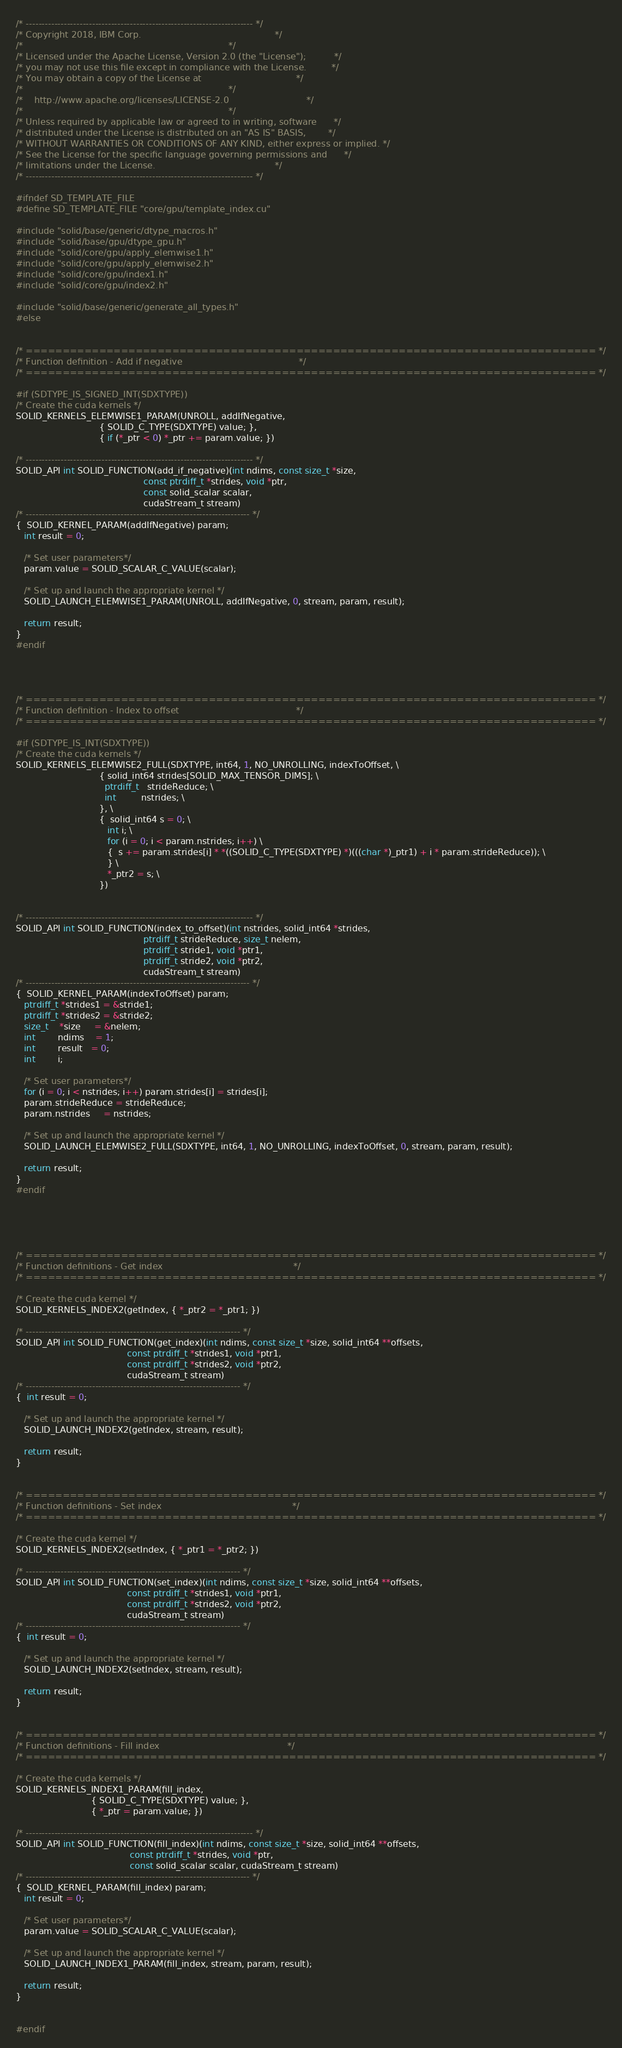Convert code to text. <code><loc_0><loc_0><loc_500><loc_500><_Cuda_>/* ------------------------------------------------------------------------ */
/* Copyright 2018, IBM Corp.                                                */
/*                                                                          */
/* Licensed under the Apache License, Version 2.0 (the "License");          */
/* you may not use this file except in compliance with the License.         */
/* You may obtain a copy of the License at                                  */
/*                                                                          */
/*    http://www.apache.org/licenses/LICENSE-2.0                            */
/*                                                                          */
/* Unless required by applicable law or agreed to in writing, software      */
/* distributed under the License is distributed on an "AS IS" BASIS,        */
/* WITHOUT WARRANTIES OR CONDITIONS OF ANY KIND, either express or implied. */
/* See the License for the specific language governing permissions and      */
/* limitations under the License.                                           */
/* ------------------------------------------------------------------------ */

#ifndef SD_TEMPLATE_FILE
#define SD_TEMPLATE_FILE "core/gpu/template_index.cu"

#include "solid/base/generic/dtype_macros.h"
#include "solid/base/gpu/dtype_gpu.h"
#include "solid/core/gpu/apply_elemwise1.h"
#include "solid/core/gpu/apply_elemwise2.h"
#include "solid/core/gpu/index1.h"
#include "solid/core/gpu/index2.h"

#include "solid/base/generic/generate_all_types.h"
#else


/* ============================================================================== */
/* Function definition - Add if negative                                          */
/* ============================================================================== */

#if (SDTYPE_IS_SIGNED_INT(SDXTYPE))
/* Create the cuda kernels */
SOLID_KERNELS_ELEMWISE1_PARAM(UNROLL, addIfNegative,
                              { SOLID_C_TYPE(SDXTYPE) value; },
                              { if (*_ptr < 0) *_ptr += param.value; })

/* ------------------------------------------------------------------------ */
SOLID_API int SOLID_FUNCTION(add_if_negative)(int ndims, const size_t *size,
                                              const ptrdiff_t *strides, void *ptr,
                                              const solid_scalar scalar,
                                              cudaStream_t stream)
/* ----------------------------------------------------------------------- */
{  SOLID_KERNEL_PARAM(addIfNegative) param;
   int result = 0;

   /* Set user parameters*/
   param.value = SOLID_SCALAR_C_VALUE(scalar);

   /* Set up and launch the appropriate kernel */
   SOLID_LAUNCH_ELEMWISE1_PARAM(UNROLL, addIfNegative, 0, stream, param, result);

   return result;
}
#endif




/* ============================================================================== */
/* Function definition - Index to offset                                          */
/* ============================================================================== */

#if (SDTYPE_IS_INT(SDXTYPE))
/* Create the cuda kernels */
SOLID_KERNELS_ELEMWISE2_FULL(SDXTYPE, int64, 1, NO_UNROLLING, indexToOffset, \
                              { solid_int64 strides[SOLID_MAX_TENSOR_DIMS]; \
                                ptrdiff_t   strideReduce; \
                                int         nstrides; \
                              }, \
                              {  solid_int64 s = 0; \
                                 int i; \
                                 for (i = 0; i < param.nstrides; i++) \
                                 {  s += param.strides[i] * *((SOLID_C_TYPE(SDXTYPE) *)(((char *)_ptr1) + i * param.strideReduce)); \
                                 } \
                                 *_ptr2 = s; \
                              })


/* ------------------------------------------------------------------------ */
SOLID_API int SOLID_FUNCTION(index_to_offset)(int nstrides, solid_int64 *strides,
                                              ptrdiff_t strideReduce, size_t nelem,
                                              ptrdiff_t stride1, void *ptr1,
                                              ptrdiff_t stride2, void *ptr2,
                                              cudaStream_t stream)
/* ----------------------------------------------------------------------- */
{  SOLID_KERNEL_PARAM(indexToOffset) param;
   ptrdiff_t *strides1 = &stride1;
   ptrdiff_t *strides2 = &stride2;
   size_t    *size     = &nelem;
   int        ndims    = 1;
   int        result   = 0;
   int        i;

   /* Set user parameters*/
   for (i = 0; i < nstrides; i++) param.strides[i] = strides[i];
   param.strideReduce = strideReduce;
   param.nstrides     = nstrides;

   /* Set up and launch the appropriate kernel */
   SOLID_LAUNCH_ELEMWISE2_FULL(SDXTYPE, int64, 1, NO_UNROLLING, indexToOffset, 0, stream, param, result);

   return result;
}
#endif





/* ============================================================================== */
/* Function definitions - Get index                                               */
/* ============================================================================== */

/* Create the cuda kernel */
SOLID_KERNELS_INDEX2(getIndex, { *_ptr2 = *_ptr1; })

/* -------------------------------------------------------------------- */
SOLID_API int SOLID_FUNCTION(get_index)(int ndims, const size_t *size, solid_int64 **offsets,
                                        const ptrdiff_t *strides1, void *ptr1,
                                        const ptrdiff_t *strides2, void *ptr2,
                                        cudaStream_t stream)
/* -------------------------------------------------------------------- */
{  int result = 0;

   /* Set up and launch the appropriate kernel */
   SOLID_LAUNCH_INDEX2(getIndex, stream, result);

   return result;
}


/* ============================================================================== */
/* Function definitions - Set index                                               */
/* ============================================================================== */

/* Create the cuda kernel */
SOLID_KERNELS_INDEX2(setIndex, { *_ptr1 = *_ptr2; })

/* -------------------------------------------------------------------- */
SOLID_API int SOLID_FUNCTION(set_index)(int ndims, const size_t *size, solid_int64 **offsets,
                                        const ptrdiff_t *strides1, void *ptr1,
                                        const ptrdiff_t *strides2, void *ptr2,
                                        cudaStream_t stream)
/* -------------------------------------------------------------------- */
{  int result = 0;

   /* Set up and launch the appropriate kernel */
   SOLID_LAUNCH_INDEX2(setIndex, stream, result);

   return result;
}


/* ============================================================================== */
/* Function definitions - Fill index                                              */
/* ============================================================================== */

/* Create the cuda kernels */
SOLID_KERNELS_INDEX1_PARAM(fill_index,
                           { SOLID_C_TYPE(SDXTYPE) value; },
                           { *_ptr = param.value; })

/* ------------------------------------------------------------------------ */
SOLID_API int SOLID_FUNCTION(fill_index)(int ndims, const size_t *size, solid_int64 **offsets,
                                         const ptrdiff_t *strides, void *ptr,
                                         const solid_scalar scalar, cudaStream_t stream)
/* ----------------------------------------------------------------------- */
{  SOLID_KERNEL_PARAM(fill_index) param;
   int result = 0;

   /* Set user parameters*/
   param.value = SOLID_SCALAR_C_VALUE(scalar);

   /* Set up and launch the appropriate kernel */
   SOLID_LAUNCH_INDEX1_PARAM(fill_index, stream, param, result);

   return result;
}


#endif
</code> 